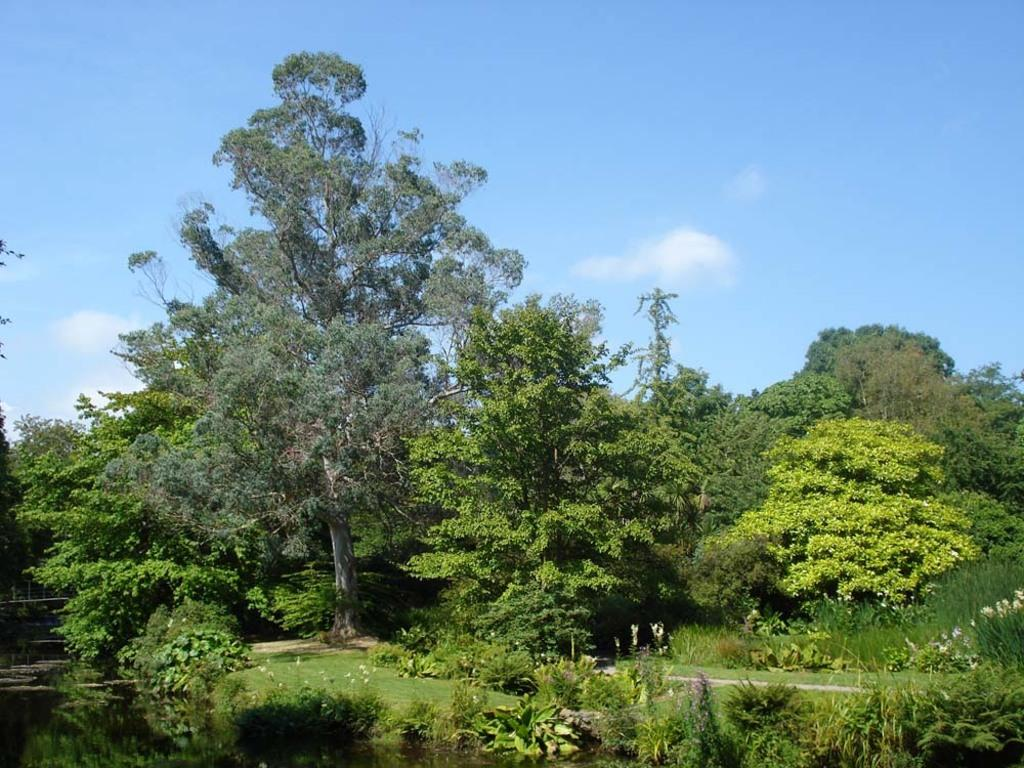What type of vegetation is located in the middle of the image? There are trees in the middle of the image. What is visible at the top of the image? The sky is visible at the top of the image. What type of vegetation is at the bottom of the image? There are bushes at the bottom of the image. What can be seen in the bottom left corner of the image? There is water in the bottom left corner of the image. What invention is being demonstrated in the image? There is no invention being demonstrated in the image; it primarily features trees, sky, bushes, and water. What is the condition of the steel in the image? There is no steel present in the image. 